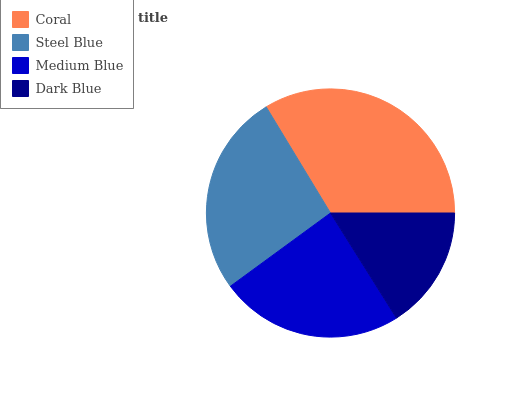Is Dark Blue the minimum?
Answer yes or no. Yes. Is Coral the maximum?
Answer yes or no. Yes. Is Steel Blue the minimum?
Answer yes or no. No. Is Steel Blue the maximum?
Answer yes or no. No. Is Coral greater than Steel Blue?
Answer yes or no. Yes. Is Steel Blue less than Coral?
Answer yes or no. Yes. Is Steel Blue greater than Coral?
Answer yes or no. No. Is Coral less than Steel Blue?
Answer yes or no. No. Is Steel Blue the high median?
Answer yes or no. Yes. Is Medium Blue the low median?
Answer yes or no. Yes. Is Coral the high median?
Answer yes or no. No. Is Coral the low median?
Answer yes or no. No. 